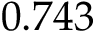Convert formula to latex. <formula><loc_0><loc_0><loc_500><loc_500>0 . 7 4 3</formula> 